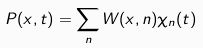Convert formula to latex. <formula><loc_0><loc_0><loc_500><loc_500>P ( x , t ) = \sum _ { n } W ( x , n ) \chi _ { n } ( t )</formula> 